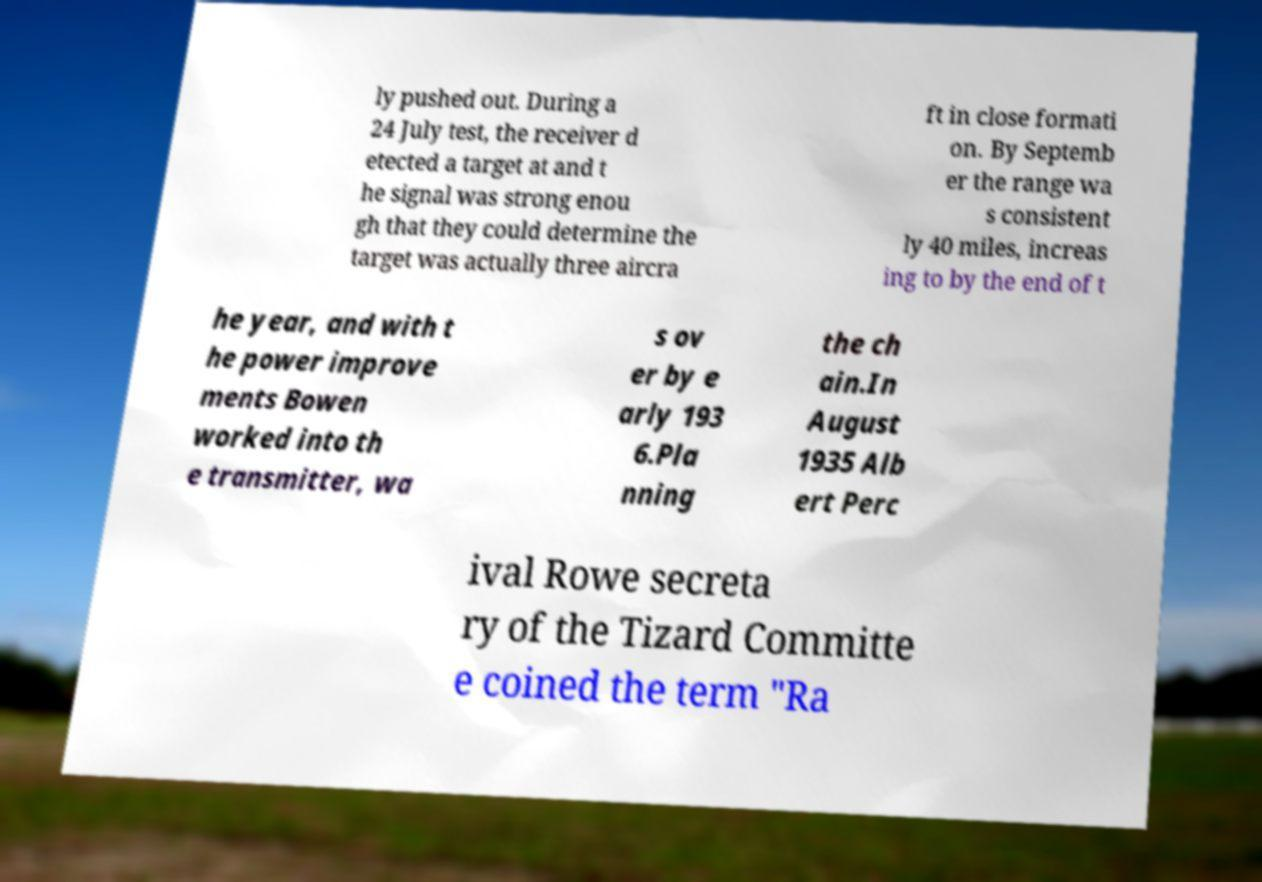Please identify and transcribe the text found in this image. ly pushed out. During a 24 July test, the receiver d etected a target at and t he signal was strong enou gh that they could determine the target was actually three aircra ft in close formati on. By Septemb er the range wa s consistent ly 40 miles, increas ing to by the end of t he year, and with t he power improve ments Bowen worked into th e transmitter, wa s ov er by e arly 193 6.Pla nning the ch ain.In August 1935 Alb ert Perc ival Rowe secreta ry of the Tizard Committe e coined the term "Ra 